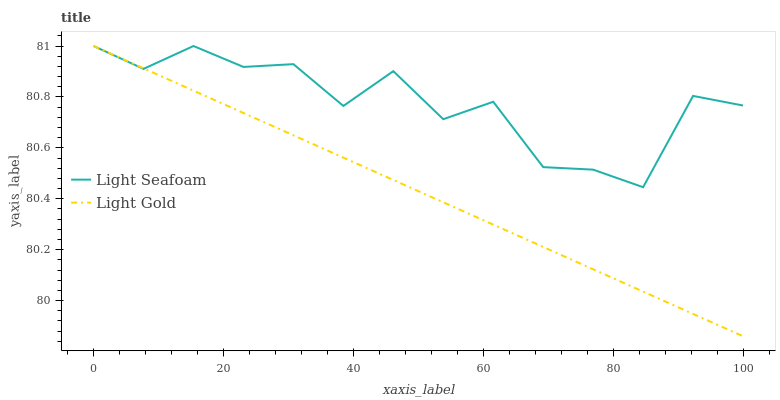Does Light Gold have the minimum area under the curve?
Answer yes or no. Yes. Does Light Seafoam have the maximum area under the curve?
Answer yes or no. Yes. Does Light Gold have the maximum area under the curve?
Answer yes or no. No. Is Light Gold the smoothest?
Answer yes or no. Yes. Is Light Seafoam the roughest?
Answer yes or no. Yes. Is Light Gold the roughest?
Answer yes or no. No. Does Light Gold have the lowest value?
Answer yes or no. Yes. Does Light Gold have the highest value?
Answer yes or no. Yes. Does Light Gold intersect Light Seafoam?
Answer yes or no. Yes. Is Light Gold less than Light Seafoam?
Answer yes or no. No. Is Light Gold greater than Light Seafoam?
Answer yes or no. No. 